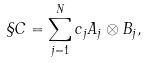<formula> <loc_0><loc_0><loc_500><loc_500>\S C = \sum _ { j = 1 } ^ { N } c _ { j } A _ { j } \otimes B _ { j } ,</formula> 